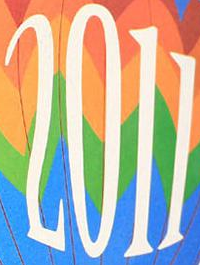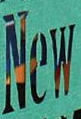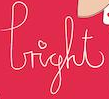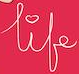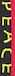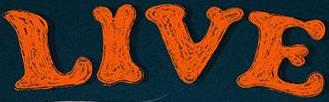What text is displayed in these images sequentially, separated by a semicolon? 2011; New; light; life; PEACE; LIVE 